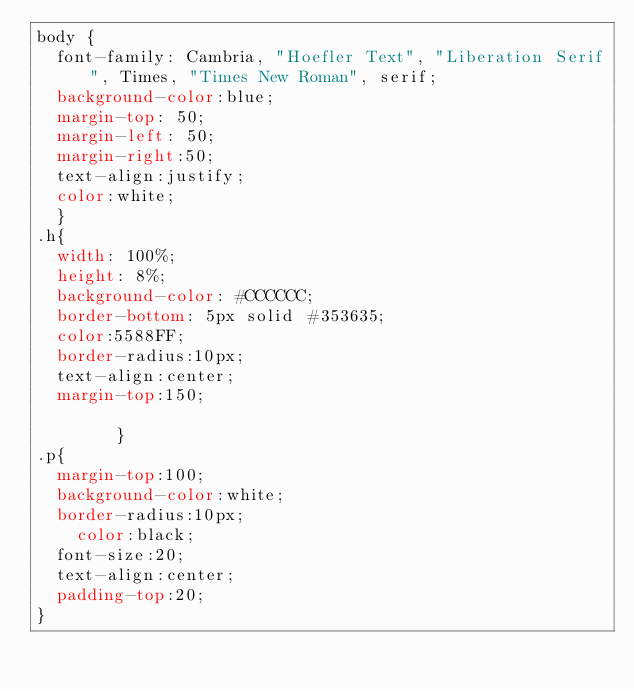Convert code to text. <code><loc_0><loc_0><loc_500><loc_500><_CSS_>body {
	font-family: Cambria, "Hoefler Text", "Liberation Serif", Times, "Times New Roman", serif;
	background-color:blue;
	margin-top: 50;
	margin-left: 50;
	margin-right:50;
	text-align:justify;
	color:white;
	}
.h{
	width: 100%;
	height: 8%;
	background-color: #CCCCCC;
	border-bottom: 5px solid #353635;
	color:5588FF;
	border-radius:10px;
	text-align:center;
	margin-top:150;
	
        }
.p{
	margin-top:100;
	background-color:white;
	border-radius:10px;
    color:black;
	font-size:20;
	text-align:center;
	padding-top:20;
}</code> 